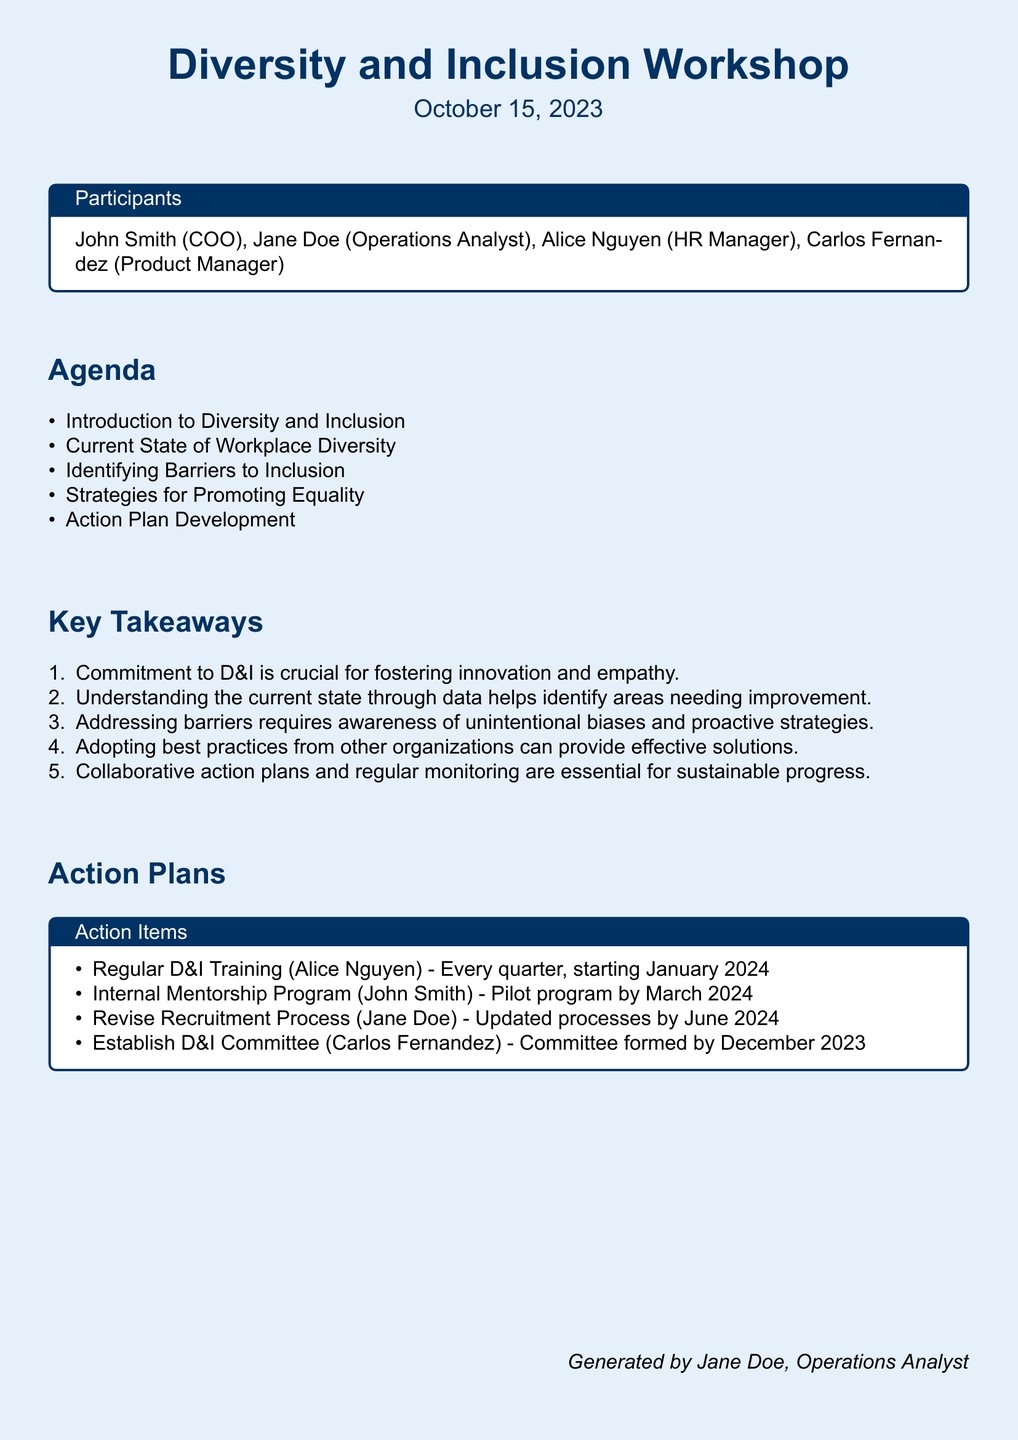What is the date of the workshop? The workshop is scheduled to take place on October 15, 2023, as indicated at the top of the document.
Answer: October 15, 2023 Who is the COO? The document lists John Smith as the COO in the participants section.
Answer: John Smith What is one key takeaway from the workshop? The document lists several key takeaways, one of which is the importance of commitment to diversity and inclusion for fostering innovation and empathy.
Answer: Commitment to D&I is crucial for fostering innovation and empathy When will the D&I training start? The action plan mentions that regular D&I training will start in January 2024.
Answer: January 2024 Who is responsible for revising the recruitment process? Jane Doe is assigned to update the recruitment processes as stated in the action items.
Answer: Jane Doe What is the deadline for establishing the D&I committee? The action plan states that the D&I committee should be formed by December 2023.
Answer: December 2023 How often will the D&I training occur? According to the action items, the D&I training will occur every quarter starting in January 2024.
Answer: Every quarter What is the main purpose of the workshop? The main purpose is to discuss strategies and plans for promoting a fair and inclusive workplace culture based on the agenda.
Answer: Promote a fair and inclusive workplace culture What is one type of barrier to inclusion mentioned? The key takeaways note that unintentional biases are a barrier that needs to be addressed.
Answer: Unintentional biases 